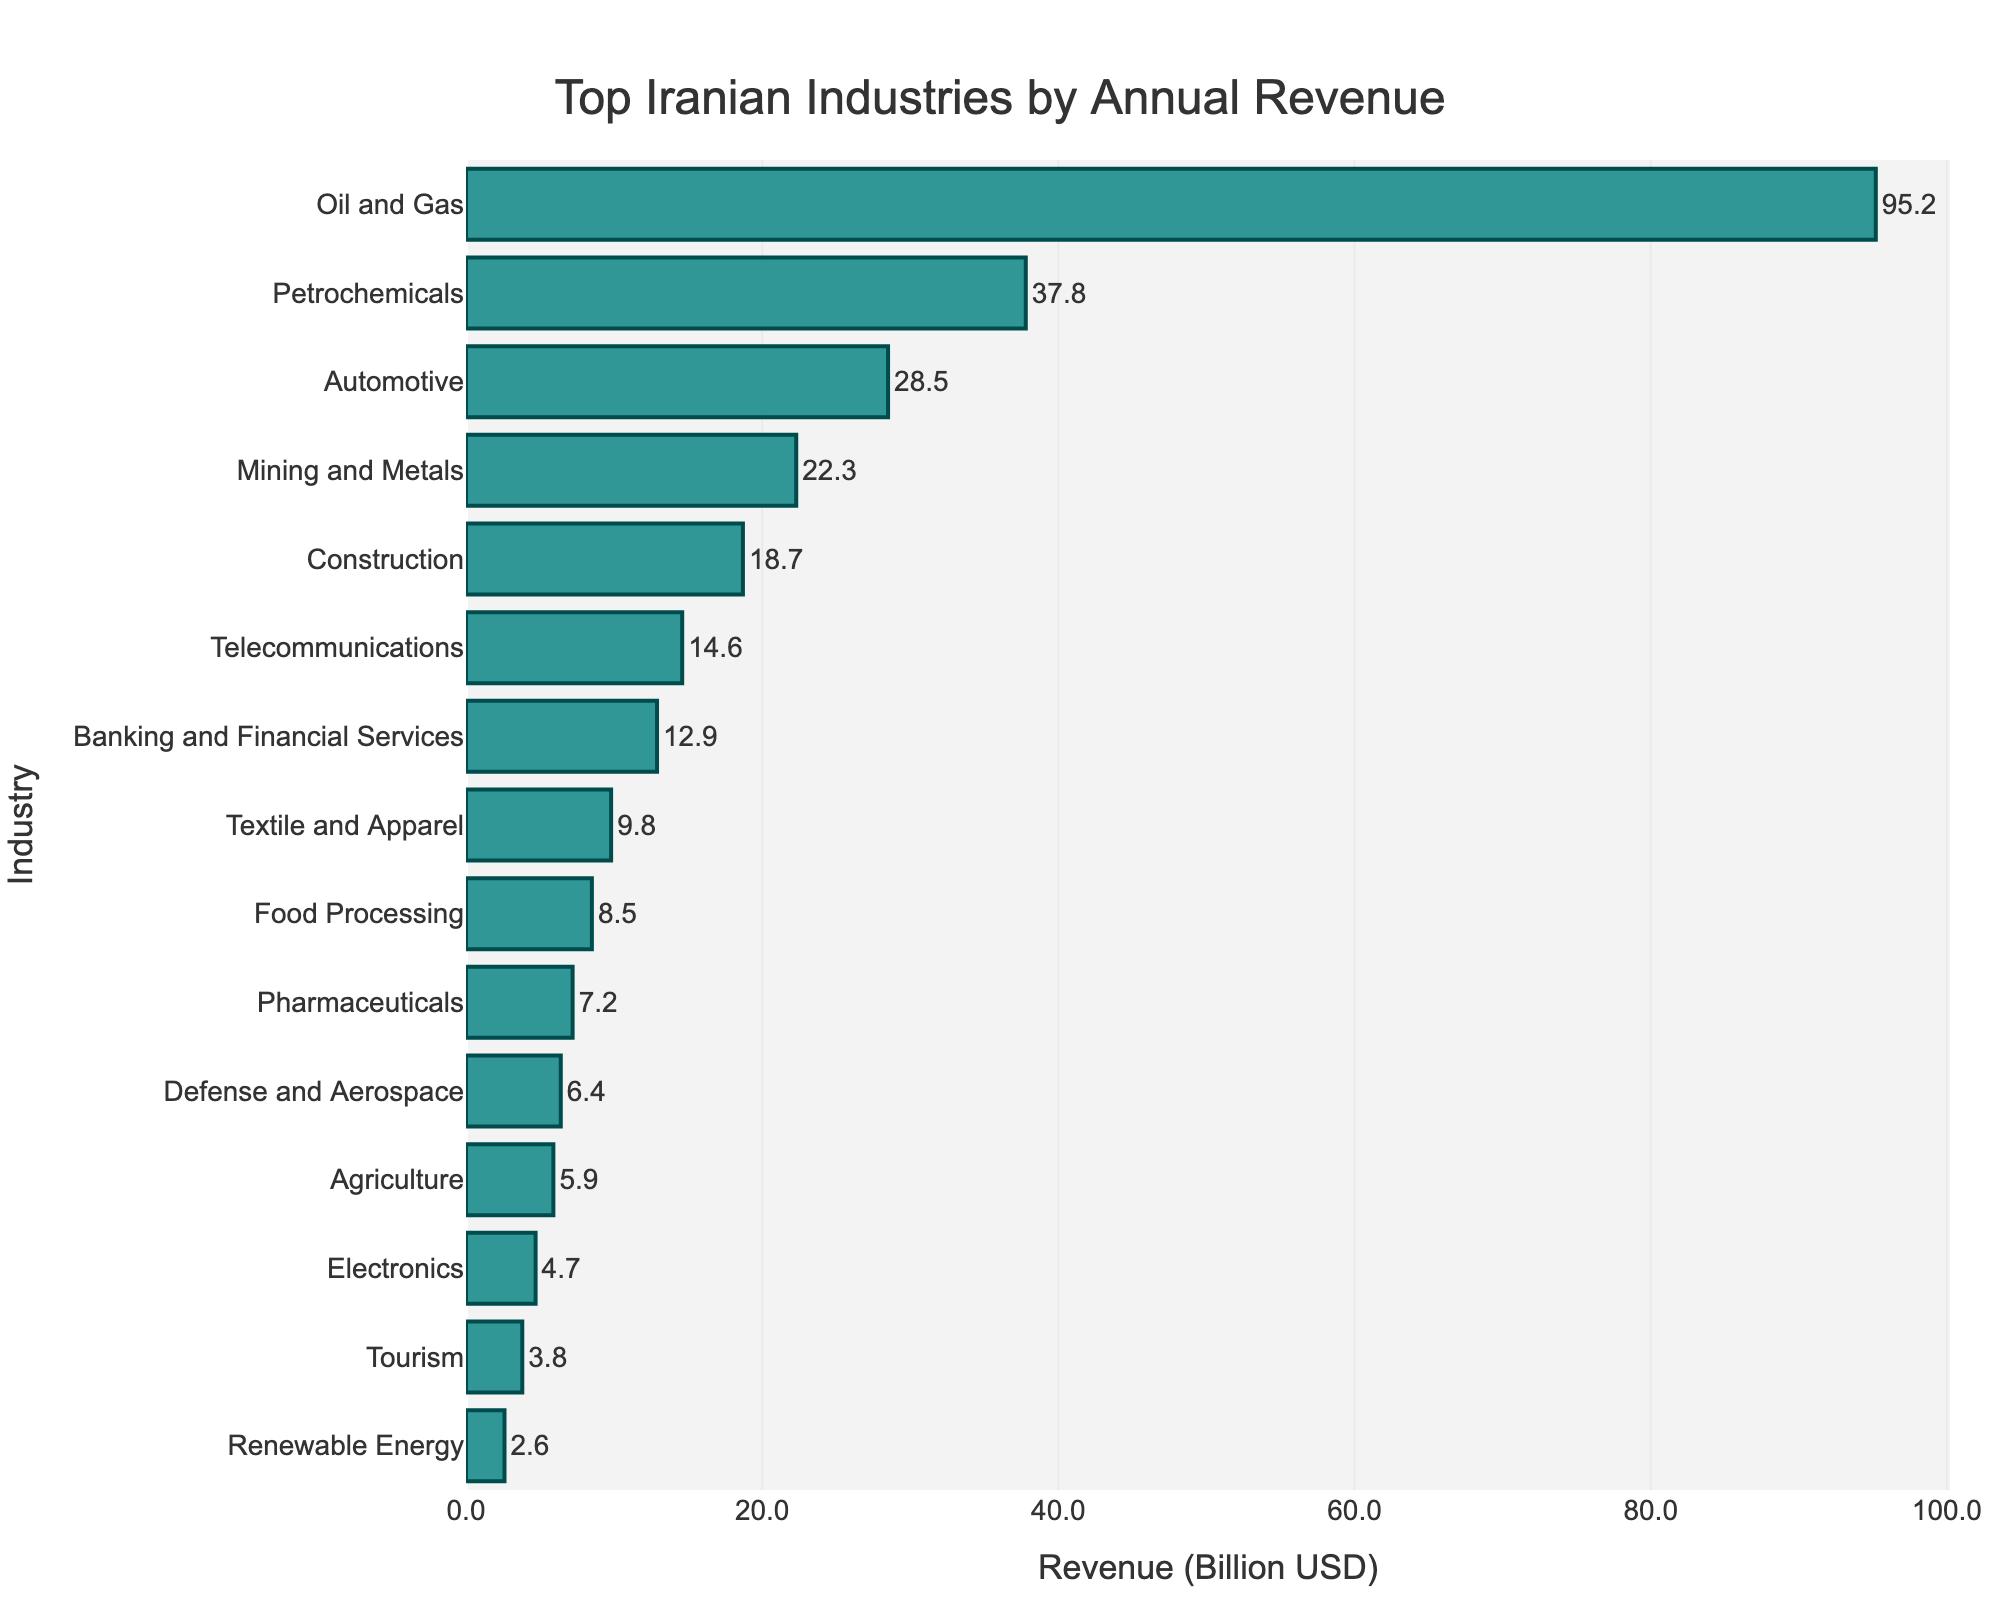What's the total annual revenue of the top three industries? To find the total annual revenue of the top three industries, we add their revenues: Oil and Gas (95.2), Petrochemicals (37.8), and Automotive (28.5). So, 95.2 + 37.8 + 28.5 = 161.5.
Answer: 161.5 Which industry has a higher annual revenue, Construction or Mining and Metals? Compare the annual revenues: Construction has 18.7 and Mining and Metals has 22.3. 22.3 is greater than 18.7, so Mining and Metals has a higher revenue.
Answer: Mining and Metals How much more revenue does the Oil and Gas industry generate compared to the Renewable Energy industry? Subtract the revenue of Renewable Energy (2.6) from Oil and Gas (95.2). So, 95.2 - 2.6 = 92.6.
Answer: 92.6 Which industry has the lowest annual revenue, and what is its value? Look for the industry with the smallest bar in the chart. Renewable Energy has the lowest annual revenue of 2.6 billion USD.
Answer: Renewable Energy, 2.6 What is the combined annual revenue of the Telecommunications and Banking and Financial Services industries? Add the revenues of Telecommunications (14.6) and Banking and Financial Services (12.9). So, 14.6 + 12.9 = 27.5.
Answer: 27.5 What is the average revenue of the Automotive, Pharmaceuticals, and Tourism industries? To find the average, add their revenues: Automotive (28.5), Pharmaceuticals (7.2), and Tourism (3.8). Then divide by 3: (28.5 + 7.2 + 3.8) / 3 = 13.1667.
Answer: 13.17 Which industry has a higher revenue, Defense and Aerospace or Agriculture, and by how much? Compare their revenues: Defense and Aerospace has 6.4 and Agriculture has 5.9. Subtract the smaller from the larger: 6.4 - 5.9 = 0.5.
Answer: Defense and Aerospace by 0.5 What is the difference in revenue between the highest revenue industry and the median revenue industry? The highest revenue industry is Oil and Gas with 95.2. To find the median, list the revenues in order and find the middle value. The revenues from highest to lowest: 95.2, 37.8, 28.5, 22.3, 18.7, 14.6, 12.9, 9.8, 8.5, 7.2, 6.4, 5.9, 4.7, 3.8, 2.6. The median is Telecommunications with 14.6. Difference: 95.2 - 14.6 = 80.6.
Answer: 80.6 